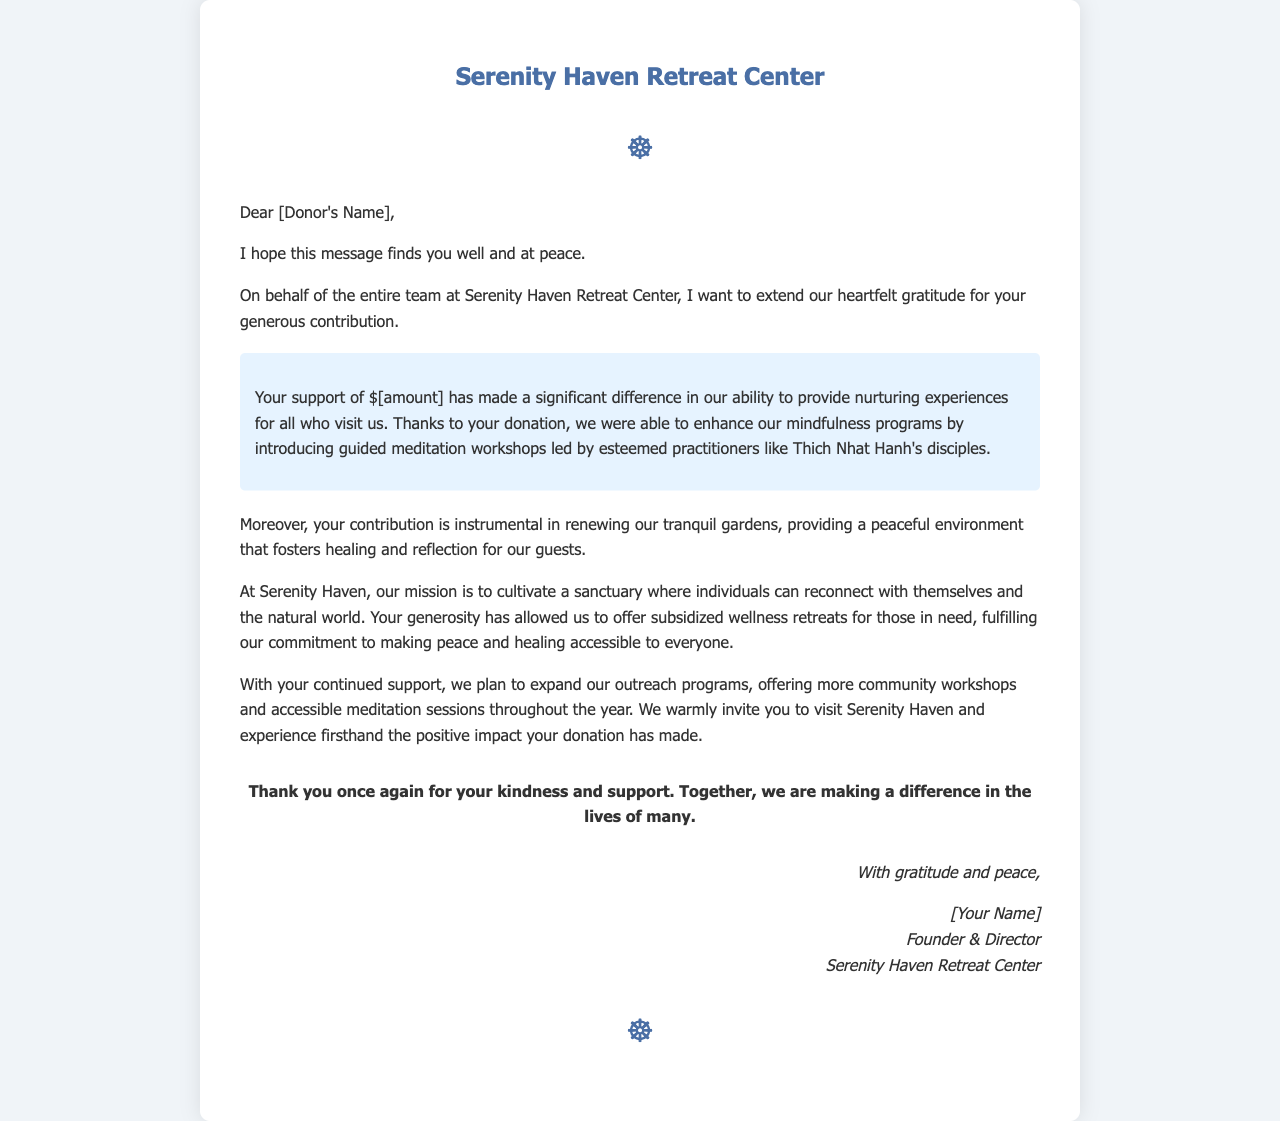What is the name of the retreat center? The document clearly states the name of the retreat center in the heading.
Answer: Serenity Haven Retreat Center Who is the letter addressed to? The greeting line indicates that the letter is directed towards a specific individual, addressed as [Donor's Name].
Answer: [Donor's Name] What is the amount of the donation mentioned? The letter specifies the donation amount in a highlighted section, represented as $[amount].
Answer: $[amount] What type of workshops were introduced with the donation? The letter explains the enhancement of mindfulness programs, specifically mentioning the type of workshops introduced.
Answer: Guided meditation workshops Who led the workshops mentioned in the letter? The document mentions esteemed practitioners, specifically referencing Thich Nhat Hanh's disciples.
Answer: Thich Nhat Hanh's disciples What is the mission of Serenity Haven? The letter outlines the core purpose of the retreat center in a dedicated section.
Answer: Cultivate a sanctuary where individuals can reconnect with themselves and the natural world What future plans does the retreat center have? The letter describes the intention to expand outreach programs in response to donations.
Answer: More community workshops and accessible meditation sessions What is expressed at the end of the letter? The closing section conveys appreciation and the significance of the donor’s support.
Answer: Gratitude and peace 